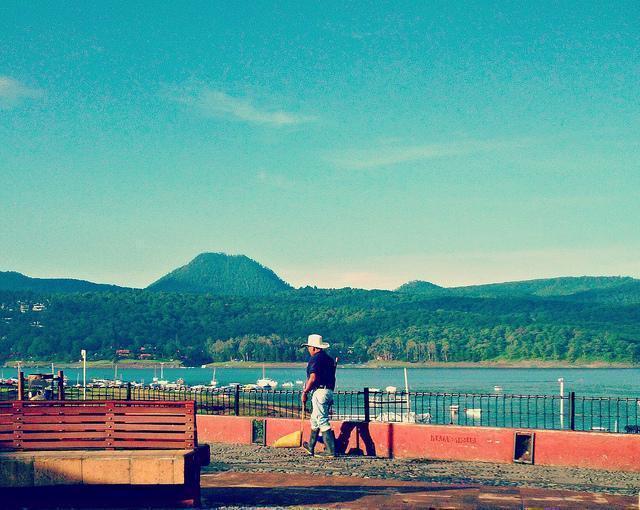What is the man wearing that is made of rubber?
Select the accurate response from the four choices given to answer the question.
Options: Vest, shirt, pants, boots. Boots. 